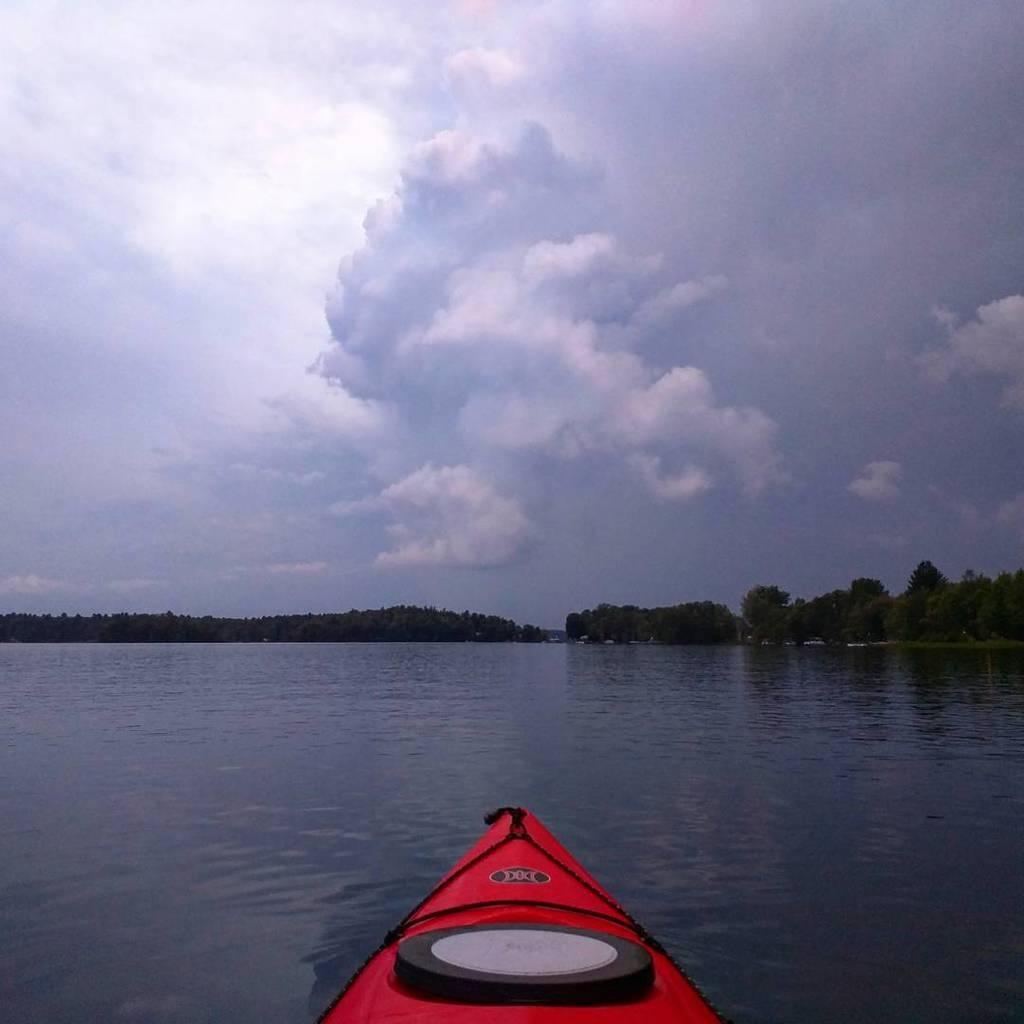What is the main subject of the image? The main subject of the image is a boat. What color is the boat? The boat is red in color. Where is the boat located? The boat is in water. What can be seen in the background of the image? There are trees visible in the background of the image. What type of disease is affecting the trees in the background of the image? There is no indication of any disease affecting the trees in the image; they appear to be healthy. 